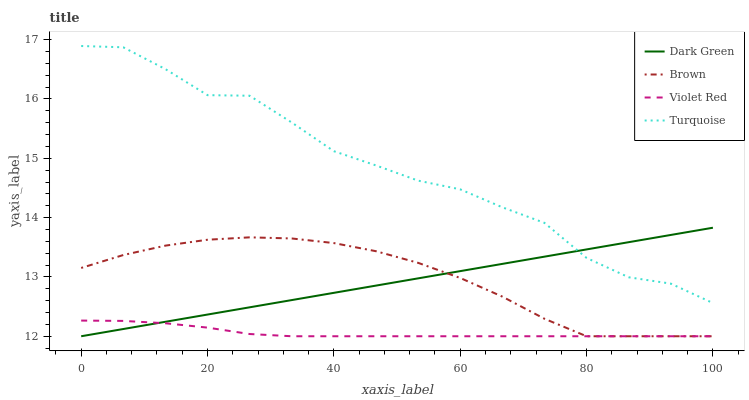Does Violet Red have the minimum area under the curve?
Answer yes or no. Yes. Does Turquoise have the maximum area under the curve?
Answer yes or no. Yes. Does Turquoise have the minimum area under the curve?
Answer yes or no. No. Does Violet Red have the maximum area under the curve?
Answer yes or no. No. Is Dark Green the smoothest?
Answer yes or no. Yes. Is Turquoise the roughest?
Answer yes or no. Yes. Is Violet Red the smoothest?
Answer yes or no. No. Is Violet Red the roughest?
Answer yes or no. No. Does Brown have the lowest value?
Answer yes or no. Yes. Does Turquoise have the lowest value?
Answer yes or no. No. Does Turquoise have the highest value?
Answer yes or no. Yes. Does Violet Red have the highest value?
Answer yes or no. No. Is Violet Red less than Turquoise?
Answer yes or no. Yes. Is Turquoise greater than Violet Red?
Answer yes or no. Yes. Does Brown intersect Violet Red?
Answer yes or no. Yes. Is Brown less than Violet Red?
Answer yes or no. No. Is Brown greater than Violet Red?
Answer yes or no. No. Does Violet Red intersect Turquoise?
Answer yes or no. No. 